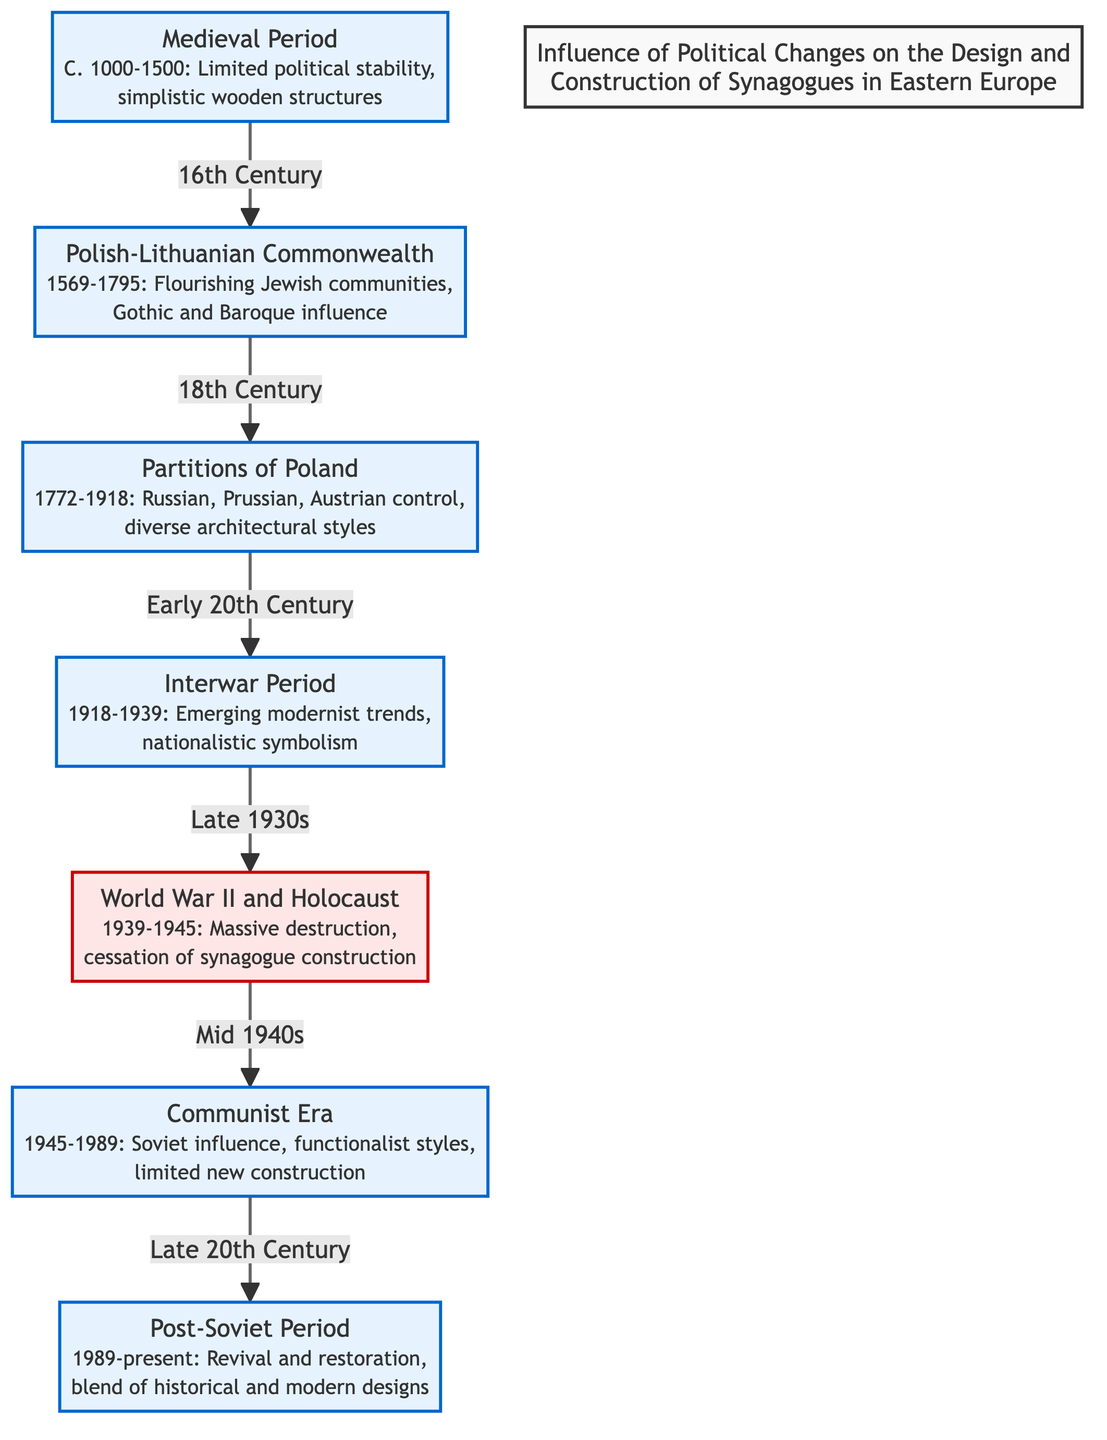What is the time span of the Medieval Period? The Medieval Period is indicated in the diagram as spanning from C. 1000 to 1500. This is explicitly stated in the label of the corresponding node.
Answer: C. 1000-1500 What major architectural influences are noted during the Polish-Lithuanian Commonwealth? The diagram specifies that during the Polish-Lithuanian Commonwealth, the architectural influences are Gothic and Baroque. This is listed in the node detailing that period.
Answer: Gothic and Baroque How many periods are represented in the diagram? By counting the distinct period nodes in the flowchart, we find there are a total of six periods represented: Medieval Period, Polish-Lithuanian Commonwealth, Partition Period, Interwar Period, Communist Era, and Post-Soviet Period.
Answer: 6 Which period comes immediately after the Interwar Period? The flowchart shows that after the Interwar Period, the next period is the World War II and Holocaust, as indicated by the directed arrow leading from one node to the next in the diagram.
Answer: World War II and Holocaust What event is marked by a cessation of synagogue construction? The diagram illustrates that during the World War II and Holocaust period, there was a massive destruction and cessation of synagogue construction, clearly described in that event's label.
Answer: World War II and Holocaust What architectural style was prominent during the Communist Era? The diagram indicates that during the Communist Era, the architectural style was influenced by functionalism. This is specified in the description of the Communist Era node.
Answer: Functionalist styles What follows the Partition Period in terms of events? According to the flowchart, the Partition Period is followed by the Interwar Period, as seen in the directional connection indicated in the diagram.
Answer: Interwar Period What was a notable trend during the Post-Soviet Period? The diagram states that the Post-Soviet Period is characterized by revival and restoration, blending historical and modern designs, which is clearly articulated in that period's description.
Answer: Revival and restoration What is the relationship between the Polish-Lithuanian Commonwealth and the Partition Period? The flowchart shows that the Polish-Lithuanian Commonwealth leads directly to the Partition Period, indicated by an arrow connecting the two nodes.
Answer: Leads to 